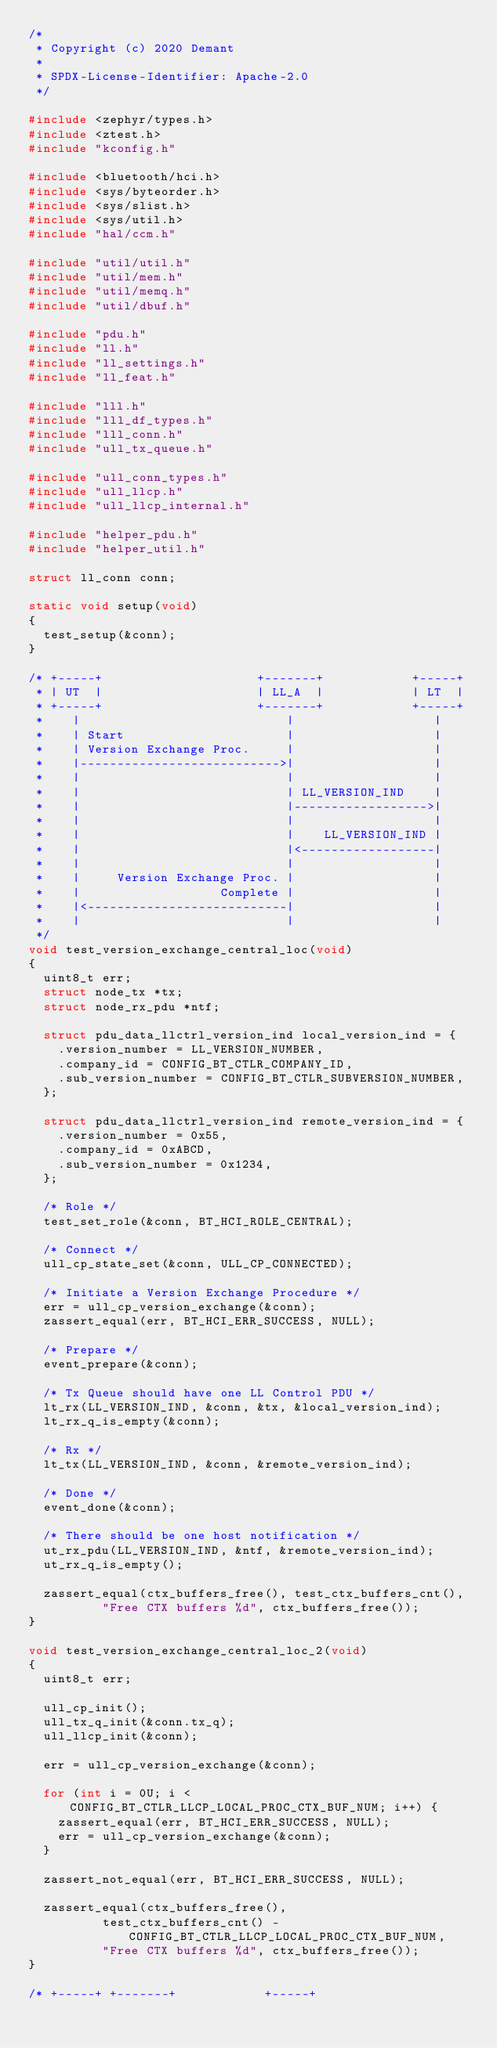Convert code to text. <code><loc_0><loc_0><loc_500><loc_500><_C_>/*
 * Copyright (c) 2020 Demant
 *
 * SPDX-License-Identifier: Apache-2.0
 */

#include <zephyr/types.h>
#include <ztest.h>
#include "kconfig.h"

#include <bluetooth/hci.h>
#include <sys/byteorder.h>
#include <sys/slist.h>
#include <sys/util.h>
#include "hal/ccm.h"

#include "util/util.h"
#include "util/mem.h"
#include "util/memq.h"
#include "util/dbuf.h"

#include "pdu.h"
#include "ll.h"
#include "ll_settings.h"
#include "ll_feat.h"

#include "lll.h"
#include "lll_df_types.h"
#include "lll_conn.h"
#include "ull_tx_queue.h"

#include "ull_conn_types.h"
#include "ull_llcp.h"
#include "ull_llcp_internal.h"

#include "helper_pdu.h"
#include "helper_util.h"

struct ll_conn conn;

static void setup(void)
{
	test_setup(&conn);
}

/* +-----+                     +-------+            +-----+
 * | UT  |                     | LL_A  |            | LT  |
 * +-----+                     +-------+            +-----+
 *    |                            |                   |
 *    | Start                      |                   |
 *    | Version Exchange Proc.     |                   |
 *    |--------------------------->|                   |
 *    |                            |                   |
 *    |                            | LL_VERSION_IND    |
 *    |                            |------------------>|
 *    |                            |                   |
 *    |                            |    LL_VERSION_IND |
 *    |                            |<------------------|
 *    |                            |                   |
 *    |     Version Exchange Proc. |                   |
 *    |                   Complete |                   |
 *    |<---------------------------|                   |
 *    |                            |                   |
 */
void test_version_exchange_central_loc(void)
{
	uint8_t err;
	struct node_tx *tx;
	struct node_rx_pdu *ntf;

	struct pdu_data_llctrl_version_ind local_version_ind = {
		.version_number = LL_VERSION_NUMBER,
		.company_id = CONFIG_BT_CTLR_COMPANY_ID,
		.sub_version_number = CONFIG_BT_CTLR_SUBVERSION_NUMBER,
	};

	struct pdu_data_llctrl_version_ind remote_version_ind = {
		.version_number = 0x55,
		.company_id = 0xABCD,
		.sub_version_number = 0x1234,
	};

	/* Role */
	test_set_role(&conn, BT_HCI_ROLE_CENTRAL);

	/* Connect */
	ull_cp_state_set(&conn, ULL_CP_CONNECTED);

	/* Initiate a Version Exchange Procedure */
	err = ull_cp_version_exchange(&conn);
	zassert_equal(err, BT_HCI_ERR_SUCCESS, NULL);

	/* Prepare */
	event_prepare(&conn);

	/* Tx Queue should have one LL Control PDU */
	lt_rx(LL_VERSION_IND, &conn, &tx, &local_version_ind);
	lt_rx_q_is_empty(&conn);

	/* Rx */
	lt_tx(LL_VERSION_IND, &conn, &remote_version_ind);

	/* Done */
	event_done(&conn);

	/* There should be one host notification */
	ut_rx_pdu(LL_VERSION_IND, &ntf, &remote_version_ind);
	ut_rx_q_is_empty();

	zassert_equal(ctx_buffers_free(), test_ctx_buffers_cnt(),
		      "Free CTX buffers %d", ctx_buffers_free());
}

void test_version_exchange_central_loc_2(void)
{
	uint8_t err;

	ull_cp_init();
	ull_tx_q_init(&conn.tx_q);
	ull_llcp_init(&conn);

	err = ull_cp_version_exchange(&conn);

	for (int i = 0U; i < CONFIG_BT_CTLR_LLCP_LOCAL_PROC_CTX_BUF_NUM; i++) {
		zassert_equal(err, BT_HCI_ERR_SUCCESS, NULL);
		err = ull_cp_version_exchange(&conn);
	}

	zassert_not_equal(err, BT_HCI_ERR_SUCCESS, NULL);

	zassert_equal(ctx_buffers_free(),
		      test_ctx_buffers_cnt() - CONFIG_BT_CTLR_LLCP_LOCAL_PROC_CTX_BUF_NUM,
		      "Free CTX buffers %d", ctx_buffers_free());
}

/* +-----+ +-------+            +-----+</code> 